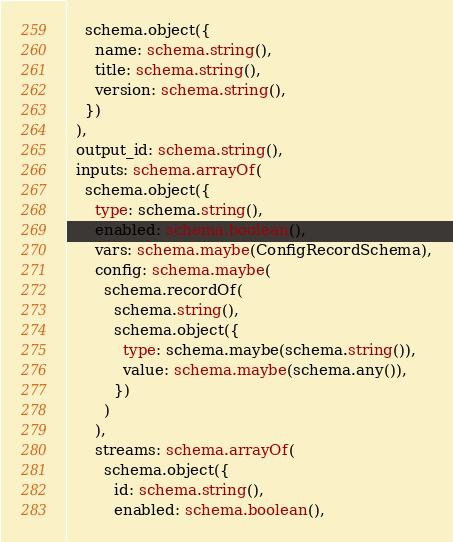Convert code to text. <code><loc_0><loc_0><loc_500><loc_500><_TypeScript_>    schema.object({
      name: schema.string(),
      title: schema.string(),
      version: schema.string(),
    })
  ),
  output_id: schema.string(),
  inputs: schema.arrayOf(
    schema.object({
      type: schema.string(),
      enabled: schema.boolean(),
      vars: schema.maybe(ConfigRecordSchema),
      config: schema.maybe(
        schema.recordOf(
          schema.string(),
          schema.object({
            type: schema.maybe(schema.string()),
            value: schema.maybe(schema.any()),
          })
        )
      ),
      streams: schema.arrayOf(
        schema.object({
          id: schema.string(),
          enabled: schema.boolean(),</code> 